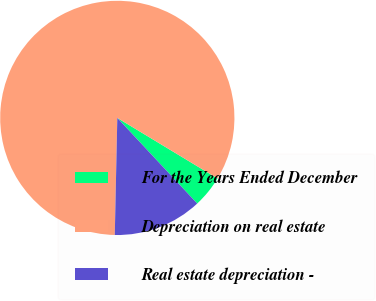Convert chart to OTSL. <chart><loc_0><loc_0><loc_500><loc_500><pie_chart><fcel>For the Years Ended December<fcel>Depreciation on real estate<fcel>Real estate depreciation -<nl><fcel>4.4%<fcel>83.3%<fcel>12.29%<nl></chart> 